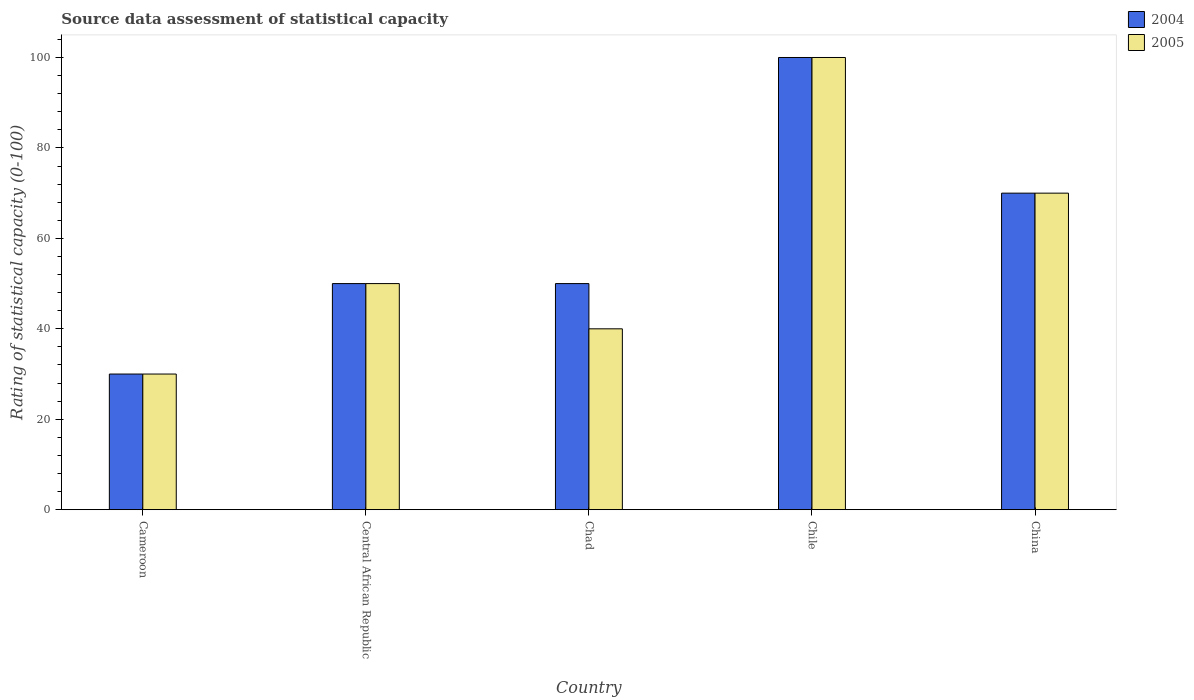Are the number of bars per tick equal to the number of legend labels?
Provide a short and direct response. Yes. Are the number of bars on each tick of the X-axis equal?
Give a very brief answer. Yes. How many bars are there on the 2nd tick from the left?
Provide a short and direct response. 2. How many bars are there on the 4th tick from the right?
Offer a very short reply. 2. What is the rating of statistical capacity in 2005 in China?
Keep it short and to the point. 70. Across all countries, what is the minimum rating of statistical capacity in 2004?
Make the answer very short. 30. In which country was the rating of statistical capacity in 2005 maximum?
Make the answer very short. Chile. In which country was the rating of statistical capacity in 2004 minimum?
Provide a short and direct response. Cameroon. What is the total rating of statistical capacity in 2005 in the graph?
Give a very brief answer. 290. Is the difference between the rating of statistical capacity in 2004 in Cameroon and Chile greater than the difference between the rating of statistical capacity in 2005 in Cameroon and Chile?
Ensure brevity in your answer.  No. What is the difference between the highest and the second highest rating of statistical capacity in 2005?
Ensure brevity in your answer.  -50. What is the difference between the highest and the lowest rating of statistical capacity in 2005?
Keep it short and to the point. 70. In how many countries, is the rating of statistical capacity in 2004 greater than the average rating of statistical capacity in 2004 taken over all countries?
Provide a succinct answer. 2. Is the sum of the rating of statistical capacity in 2004 in Central African Republic and China greater than the maximum rating of statistical capacity in 2005 across all countries?
Make the answer very short. Yes. Are all the bars in the graph horizontal?
Provide a short and direct response. No. How many countries are there in the graph?
Keep it short and to the point. 5. Are the values on the major ticks of Y-axis written in scientific E-notation?
Provide a succinct answer. No. What is the title of the graph?
Provide a short and direct response. Source data assessment of statistical capacity. Does "1965" appear as one of the legend labels in the graph?
Ensure brevity in your answer.  No. What is the label or title of the X-axis?
Offer a terse response. Country. What is the label or title of the Y-axis?
Offer a very short reply. Rating of statistical capacity (0-100). What is the Rating of statistical capacity (0-100) in 2005 in Cameroon?
Offer a terse response. 30. What is the Rating of statistical capacity (0-100) in 2004 in Central African Republic?
Your answer should be compact. 50. What is the Rating of statistical capacity (0-100) of 2005 in Central African Republic?
Your answer should be very brief. 50. What is the Rating of statistical capacity (0-100) in 2005 in Chad?
Keep it short and to the point. 40. What is the Rating of statistical capacity (0-100) of 2005 in Chile?
Your answer should be compact. 100. What is the Rating of statistical capacity (0-100) of 2004 in China?
Provide a succinct answer. 70. What is the Rating of statistical capacity (0-100) of 2005 in China?
Make the answer very short. 70. Across all countries, what is the maximum Rating of statistical capacity (0-100) in 2005?
Give a very brief answer. 100. Across all countries, what is the minimum Rating of statistical capacity (0-100) in 2005?
Provide a succinct answer. 30. What is the total Rating of statistical capacity (0-100) in 2004 in the graph?
Give a very brief answer. 300. What is the total Rating of statistical capacity (0-100) in 2005 in the graph?
Your answer should be compact. 290. What is the difference between the Rating of statistical capacity (0-100) in 2004 in Cameroon and that in Central African Republic?
Offer a terse response. -20. What is the difference between the Rating of statistical capacity (0-100) in 2005 in Cameroon and that in Central African Republic?
Provide a short and direct response. -20. What is the difference between the Rating of statistical capacity (0-100) in 2004 in Cameroon and that in Chad?
Your answer should be compact. -20. What is the difference between the Rating of statistical capacity (0-100) of 2005 in Cameroon and that in Chad?
Provide a succinct answer. -10. What is the difference between the Rating of statistical capacity (0-100) of 2004 in Cameroon and that in Chile?
Your answer should be compact. -70. What is the difference between the Rating of statistical capacity (0-100) in 2005 in Cameroon and that in Chile?
Make the answer very short. -70. What is the difference between the Rating of statistical capacity (0-100) of 2004 in Cameroon and that in China?
Ensure brevity in your answer.  -40. What is the difference between the Rating of statistical capacity (0-100) in 2005 in Cameroon and that in China?
Your answer should be very brief. -40. What is the difference between the Rating of statistical capacity (0-100) of 2004 in Central African Republic and that in Chad?
Provide a succinct answer. 0. What is the difference between the Rating of statistical capacity (0-100) in 2005 in Central African Republic and that in Chile?
Ensure brevity in your answer.  -50. What is the difference between the Rating of statistical capacity (0-100) in 2004 in Central African Republic and that in China?
Offer a very short reply. -20. What is the difference between the Rating of statistical capacity (0-100) in 2005 in Central African Republic and that in China?
Your answer should be very brief. -20. What is the difference between the Rating of statistical capacity (0-100) of 2005 in Chad and that in Chile?
Offer a very short reply. -60. What is the difference between the Rating of statistical capacity (0-100) in 2004 in Chile and that in China?
Your answer should be very brief. 30. What is the difference between the Rating of statistical capacity (0-100) in 2004 in Cameroon and the Rating of statistical capacity (0-100) in 2005 in Central African Republic?
Ensure brevity in your answer.  -20. What is the difference between the Rating of statistical capacity (0-100) of 2004 in Cameroon and the Rating of statistical capacity (0-100) of 2005 in Chad?
Offer a very short reply. -10. What is the difference between the Rating of statistical capacity (0-100) in 2004 in Cameroon and the Rating of statistical capacity (0-100) in 2005 in Chile?
Keep it short and to the point. -70. What is the difference between the Rating of statistical capacity (0-100) in 2004 in Central African Republic and the Rating of statistical capacity (0-100) in 2005 in Chad?
Provide a succinct answer. 10. What is the difference between the Rating of statistical capacity (0-100) of 2004 in Central African Republic and the Rating of statistical capacity (0-100) of 2005 in Chile?
Ensure brevity in your answer.  -50. What is the difference between the Rating of statistical capacity (0-100) of 2004 in Central African Republic and the Rating of statistical capacity (0-100) of 2005 in China?
Provide a short and direct response. -20. What is the difference between the Rating of statistical capacity (0-100) in 2004 in Chad and the Rating of statistical capacity (0-100) in 2005 in Chile?
Make the answer very short. -50. What is the difference between the Rating of statistical capacity (0-100) of 2004 in Chad and the Rating of statistical capacity (0-100) of 2005 in China?
Your answer should be very brief. -20. What is the difference between the Rating of statistical capacity (0-100) in 2004 in Chile and the Rating of statistical capacity (0-100) in 2005 in China?
Your response must be concise. 30. What is the average Rating of statistical capacity (0-100) in 2004 per country?
Keep it short and to the point. 60. What is the average Rating of statistical capacity (0-100) of 2005 per country?
Provide a succinct answer. 58. What is the difference between the Rating of statistical capacity (0-100) of 2004 and Rating of statistical capacity (0-100) of 2005 in Central African Republic?
Make the answer very short. 0. What is the difference between the Rating of statistical capacity (0-100) in 2004 and Rating of statistical capacity (0-100) in 2005 in Chile?
Provide a short and direct response. 0. What is the ratio of the Rating of statistical capacity (0-100) of 2004 in Cameroon to that in Central African Republic?
Keep it short and to the point. 0.6. What is the ratio of the Rating of statistical capacity (0-100) of 2005 in Cameroon to that in Central African Republic?
Your answer should be compact. 0.6. What is the ratio of the Rating of statistical capacity (0-100) of 2004 in Cameroon to that in Chad?
Ensure brevity in your answer.  0.6. What is the ratio of the Rating of statistical capacity (0-100) of 2005 in Cameroon to that in Chad?
Offer a terse response. 0.75. What is the ratio of the Rating of statistical capacity (0-100) of 2005 in Cameroon to that in Chile?
Make the answer very short. 0.3. What is the ratio of the Rating of statistical capacity (0-100) in 2004 in Cameroon to that in China?
Give a very brief answer. 0.43. What is the ratio of the Rating of statistical capacity (0-100) in 2005 in Cameroon to that in China?
Your answer should be compact. 0.43. What is the ratio of the Rating of statistical capacity (0-100) of 2005 in Central African Republic to that in Chile?
Offer a terse response. 0.5. What is the ratio of the Rating of statistical capacity (0-100) in 2004 in Central African Republic to that in China?
Give a very brief answer. 0.71. What is the ratio of the Rating of statistical capacity (0-100) in 2004 in Chad to that in China?
Ensure brevity in your answer.  0.71. What is the ratio of the Rating of statistical capacity (0-100) of 2004 in Chile to that in China?
Keep it short and to the point. 1.43. What is the ratio of the Rating of statistical capacity (0-100) in 2005 in Chile to that in China?
Your answer should be compact. 1.43. What is the difference between the highest and the lowest Rating of statistical capacity (0-100) of 2005?
Your response must be concise. 70. 